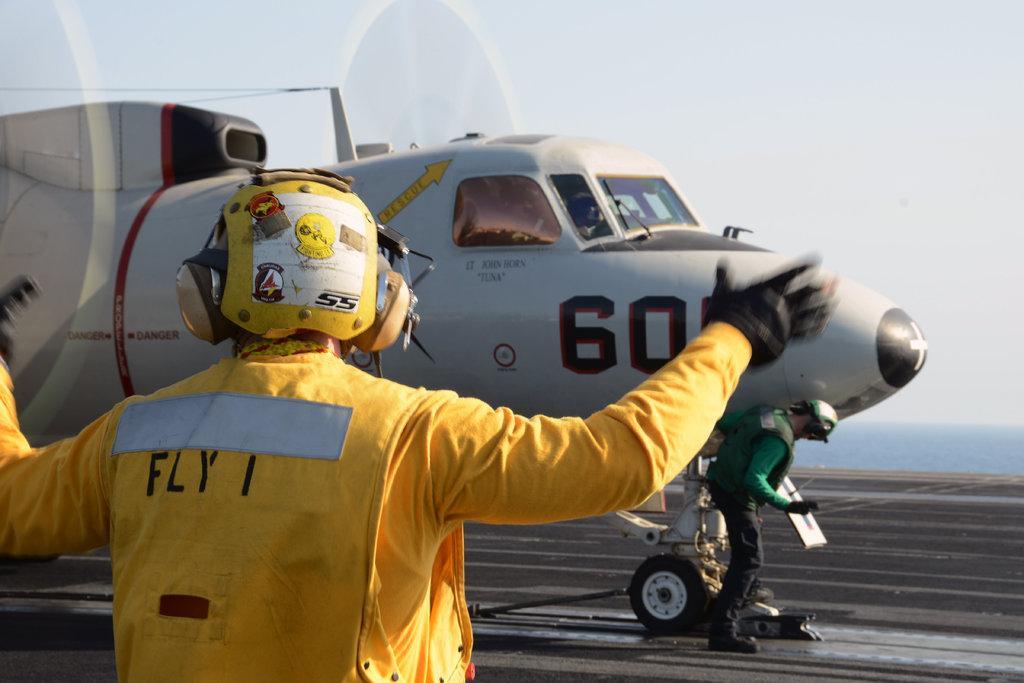Can you describe this image briefly? In this picture I can see a man is wearing yellow color dress and helmet. In the background I can see an aeroplane on the road and the sky. 